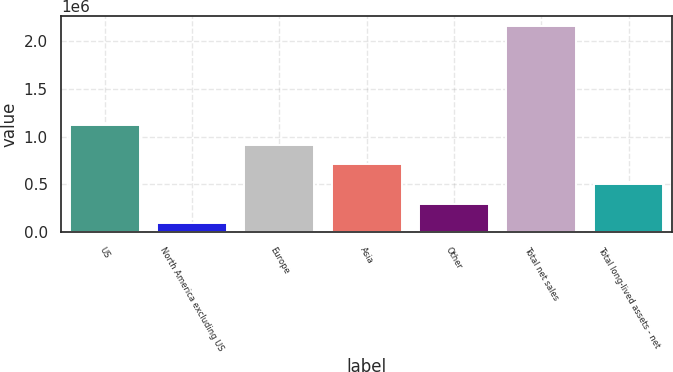Convert chart. <chart><loc_0><loc_0><loc_500><loc_500><bar_chart><fcel>US<fcel>North America excluding US<fcel>Europe<fcel>Asia<fcel>Other<fcel>Total net sales<fcel>Total long-lived assets - net<nl><fcel>1.12184e+06<fcel>95917<fcel>916657<fcel>711472<fcel>301102<fcel>2.14777e+06<fcel>506287<nl></chart> 